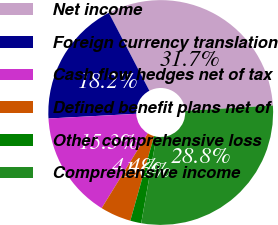Convert chart to OTSL. <chart><loc_0><loc_0><loc_500><loc_500><pie_chart><fcel>Net income<fcel>Foreign currency translation<fcel>Cash flow hedges net of tax<fcel>Defined benefit plans net of<fcel>Other comprehensive loss<fcel>Comprehensive income<nl><fcel>31.65%<fcel>18.21%<fcel>15.34%<fcel>4.45%<fcel>1.58%<fcel>28.77%<nl></chart> 